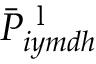Convert formula to latex. <formula><loc_0><loc_0><loc_500><loc_500>\bar { P } _ { i y m d h } ^ { l }</formula> 